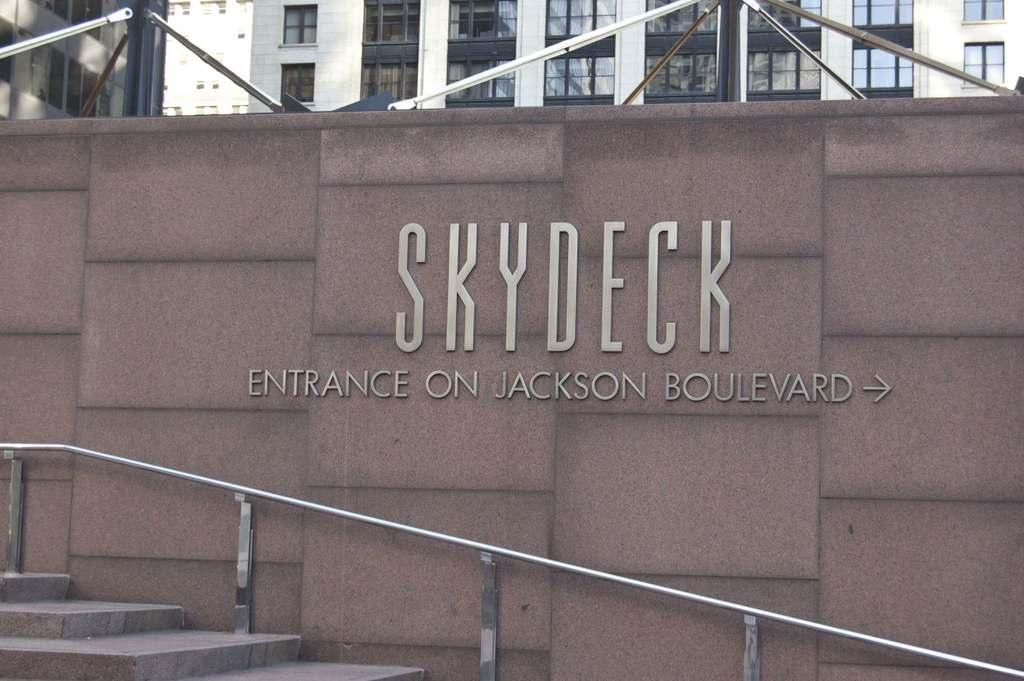What is written or depicted on the wall in the image? There is a wall with text in the image, but we cannot determine the specific content from the image alone. What is located in front of the wall? There is a staircase in front of the wall. What can be seen in the distance at the top of the image? There are buildings visible at the top of the image. What material are the rods in front of the buildings made of? The rods in front of the buildings are made of metal. What type of rhythm can be heard coming from the wall in the image? There is no indication of sound or rhythm in the image, as it features a wall with text, a staircase, buildings, and metal rods. 